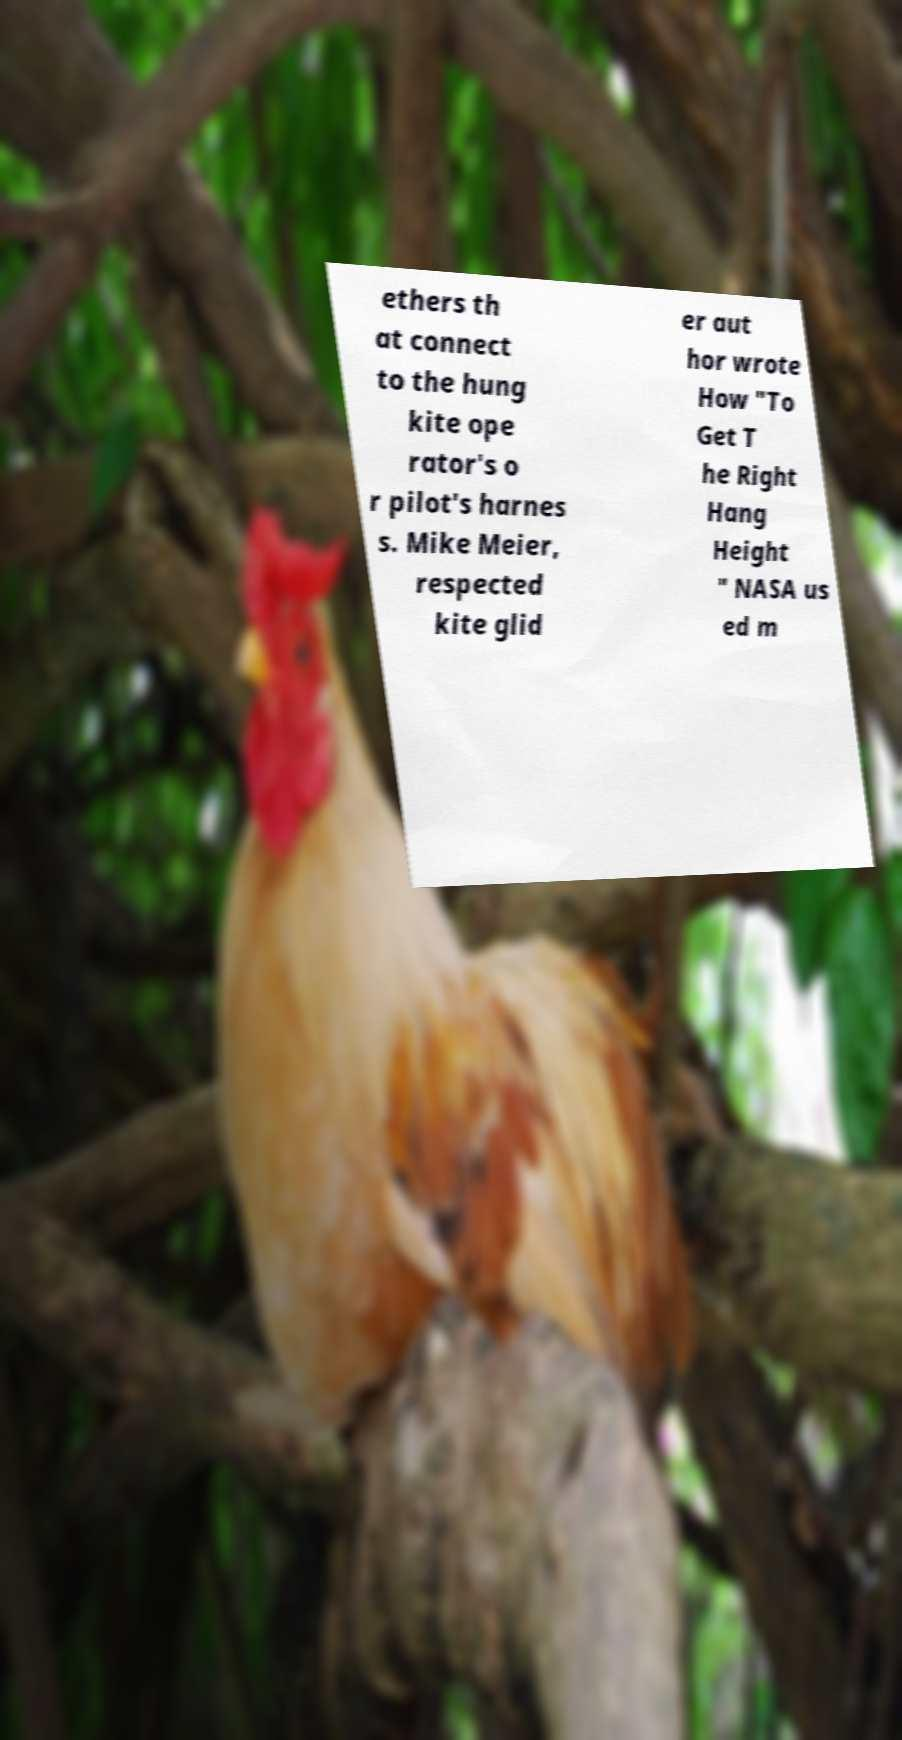Please read and relay the text visible in this image. What does it say? ethers th at connect to the hung kite ope rator's o r pilot's harnes s. Mike Meier, respected kite glid er aut hor wrote How "To Get T he Right Hang Height " NASA us ed m 